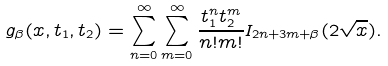Convert formula to latex. <formula><loc_0><loc_0><loc_500><loc_500>g _ { \beta } ( x , t _ { 1 } , t _ { 2 } ) = \sum _ { n = 0 } ^ { \infty } \sum _ { m = 0 } ^ { \infty } \frac { t _ { 1 } ^ { n } t _ { 2 } ^ { m } } { n ! m ! } I _ { 2 n + 3 m + \beta } ( 2 \sqrt { x } ) .</formula> 